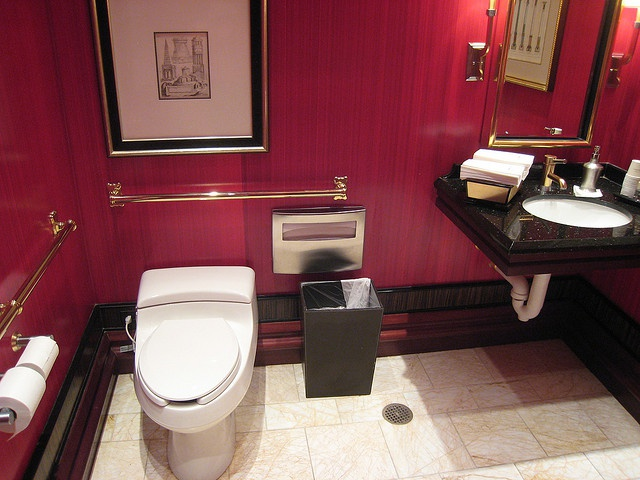Describe the objects in this image and their specific colors. I can see toilet in maroon, white, darkgray, lightgray, and tan tones, sink in maroon, white, gray, darkgray, and lightgray tones, book in maroon, white, gray, tan, and darkgray tones, bottle in maroon, darkgray, gray, and black tones, and cup in maroon, tan, and ivory tones in this image. 